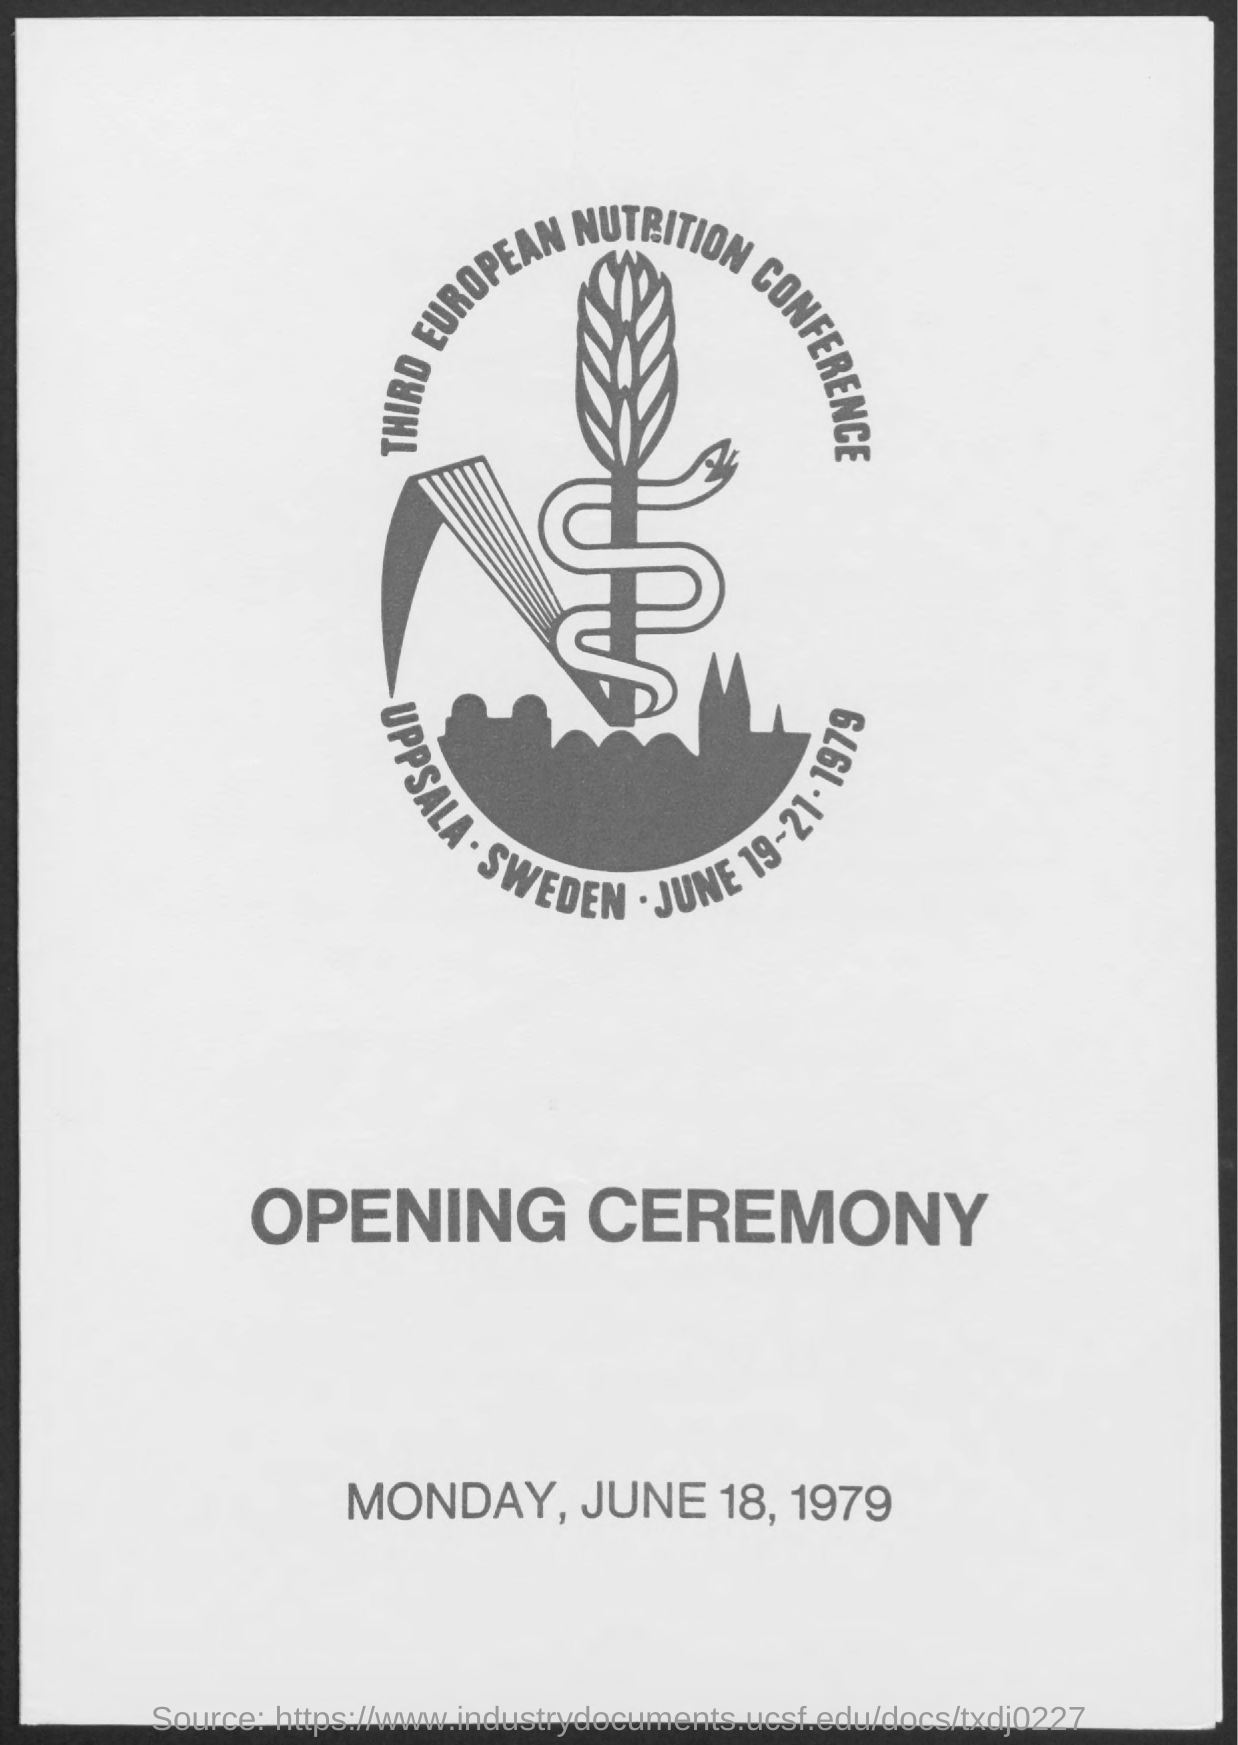When was the OPENING CEREMONY of THIRD EUROPEAN NUTRITION CONFERENCE?
Your answer should be very brief. MONDAY, JUNE 18, 1979. 